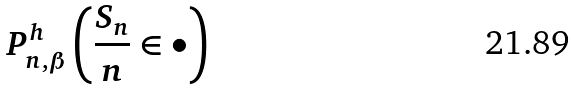<formula> <loc_0><loc_0><loc_500><loc_500>P _ { n , \beta } ^ { h } \left ( \frac { S _ { n } } { n } \in \bullet \right )</formula> 